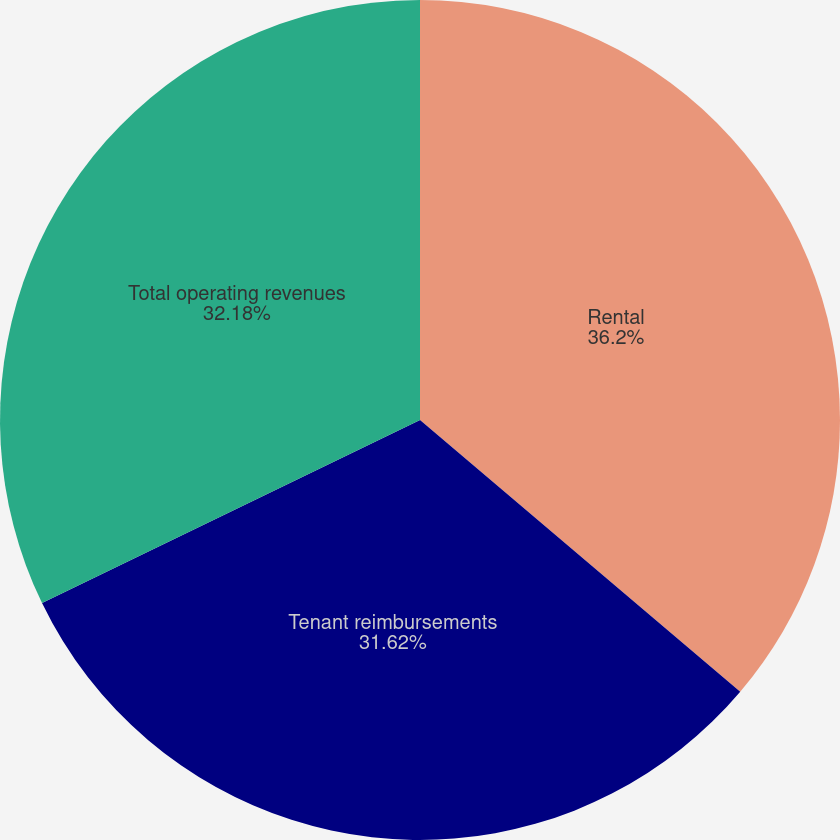Convert chart to OTSL. <chart><loc_0><loc_0><loc_500><loc_500><pie_chart><fcel>Rental<fcel>Tenant reimbursements<fcel>Total operating revenues<nl><fcel>36.2%<fcel>31.62%<fcel>32.18%<nl></chart> 